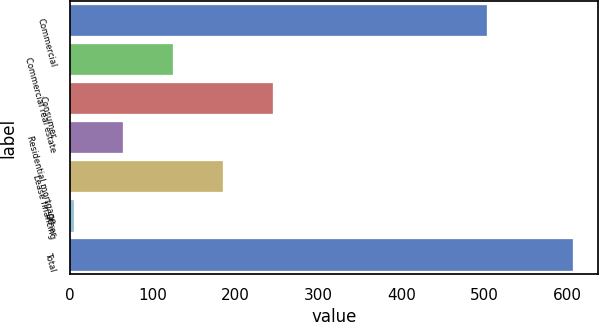Convert chart. <chart><loc_0><loc_0><loc_500><loc_500><bar_chart><fcel>Commercial<fcel>Commercial real estate<fcel>Consumer<fcel>Residential mortgage<fcel>Lease financing<fcel>Other<fcel>Total<nl><fcel>503<fcel>124.6<fcel>245.2<fcel>64.3<fcel>184.9<fcel>4<fcel>607<nl></chart> 